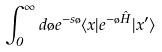Convert formula to latex. <formula><loc_0><loc_0><loc_500><loc_500>\int _ { 0 } ^ { \infty } d \tau e ^ { - s \tau } \langle { x } | { e ^ { - \tau \hat { H } } } | { x ^ { \prime } } \rangle</formula> 